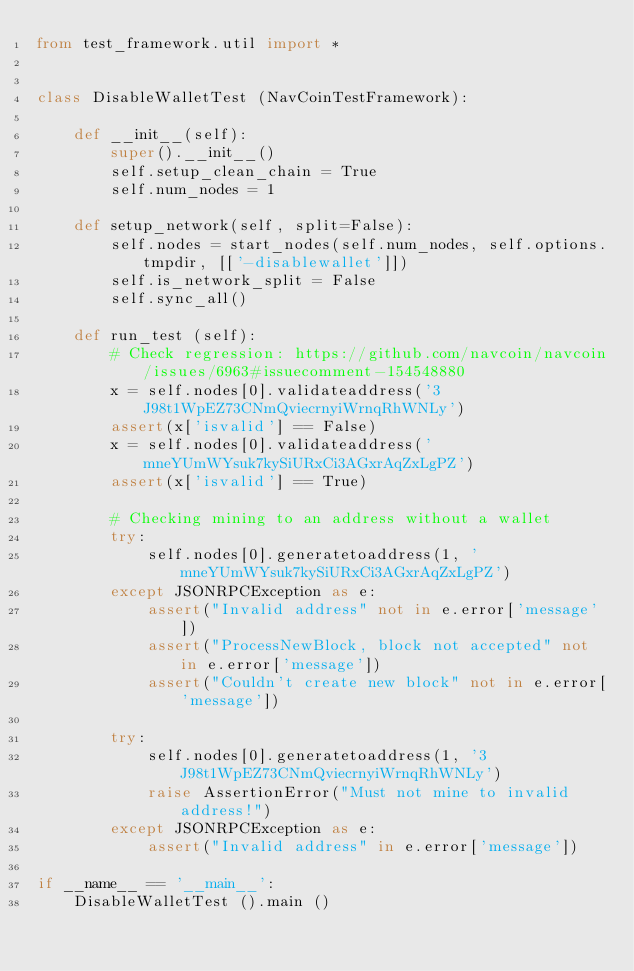Convert code to text. <code><loc_0><loc_0><loc_500><loc_500><_Python_>from test_framework.util import *


class DisableWalletTest (NavCoinTestFramework):

    def __init__(self):
        super().__init__()
        self.setup_clean_chain = True
        self.num_nodes = 1

    def setup_network(self, split=False):
        self.nodes = start_nodes(self.num_nodes, self.options.tmpdir, [['-disablewallet']])
        self.is_network_split = False
        self.sync_all()

    def run_test (self):
        # Check regression: https://github.com/navcoin/navcoin/issues/6963#issuecomment-154548880
        x = self.nodes[0].validateaddress('3J98t1WpEZ73CNmQviecrnyiWrnqRhWNLy')
        assert(x['isvalid'] == False)
        x = self.nodes[0].validateaddress('mneYUmWYsuk7kySiURxCi3AGxrAqZxLgPZ')
        assert(x['isvalid'] == True)

        # Checking mining to an address without a wallet
        try:
            self.nodes[0].generatetoaddress(1, 'mneYUmWYsuk7kySiURxCi3AGxrAqZxLgPZ')
        except JSONRPCException as e:
            assert("Invalid address" not in e.error['message'])
            assert("ProcessNewBlock, block not accepted" not in e.error['message'])
            assert("Couldn't create new block" not in e.error['message'])

        try:
            self.nodes[0].generatetoaddress(1, '3J98t1WpEZ73CNmQviecrnyiWrnqRhWNLy')
            raise AssertionError("Must not mine to invalid address!")
        except JSONRPCException as e:
            assert("Invalid address" in e.error['message'])

if __name__ == '__main__':
    DisableWalletTest ().main ()
</code> 